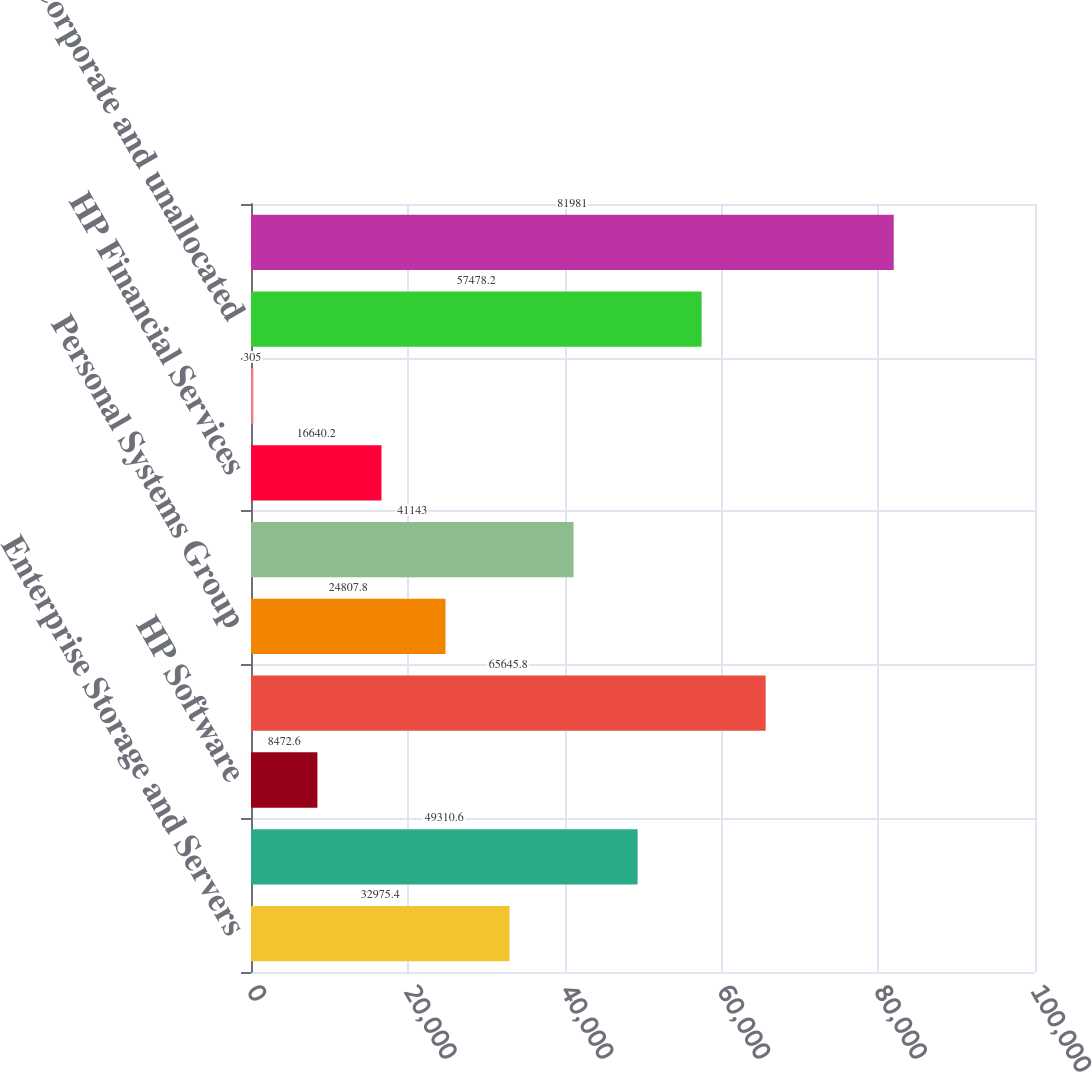<chart> <loc_0><loc_0><loc_500><loc_500><bar_chart><fcel>Enterprise Storage and Servers<fcel>HP Services<fcel>HP Software<fcel>Technology Solutions Group<fcel>Personal Systems Group<fcel>Imaging and Printing Group<fcel>HP Financial Services<fcel>Corporate Investments<fcel>Corporate and unallocated<fcel>Total HP consolidated assets<nl><fcel>32975.4<fcel>49310.6<fcel>8472.6<fcel>65645.8<fcel>24807.8<fcel>41143<fcel>16640.2<fcel>305<fcel>57478.2<fcel>81981<nl></chart> 